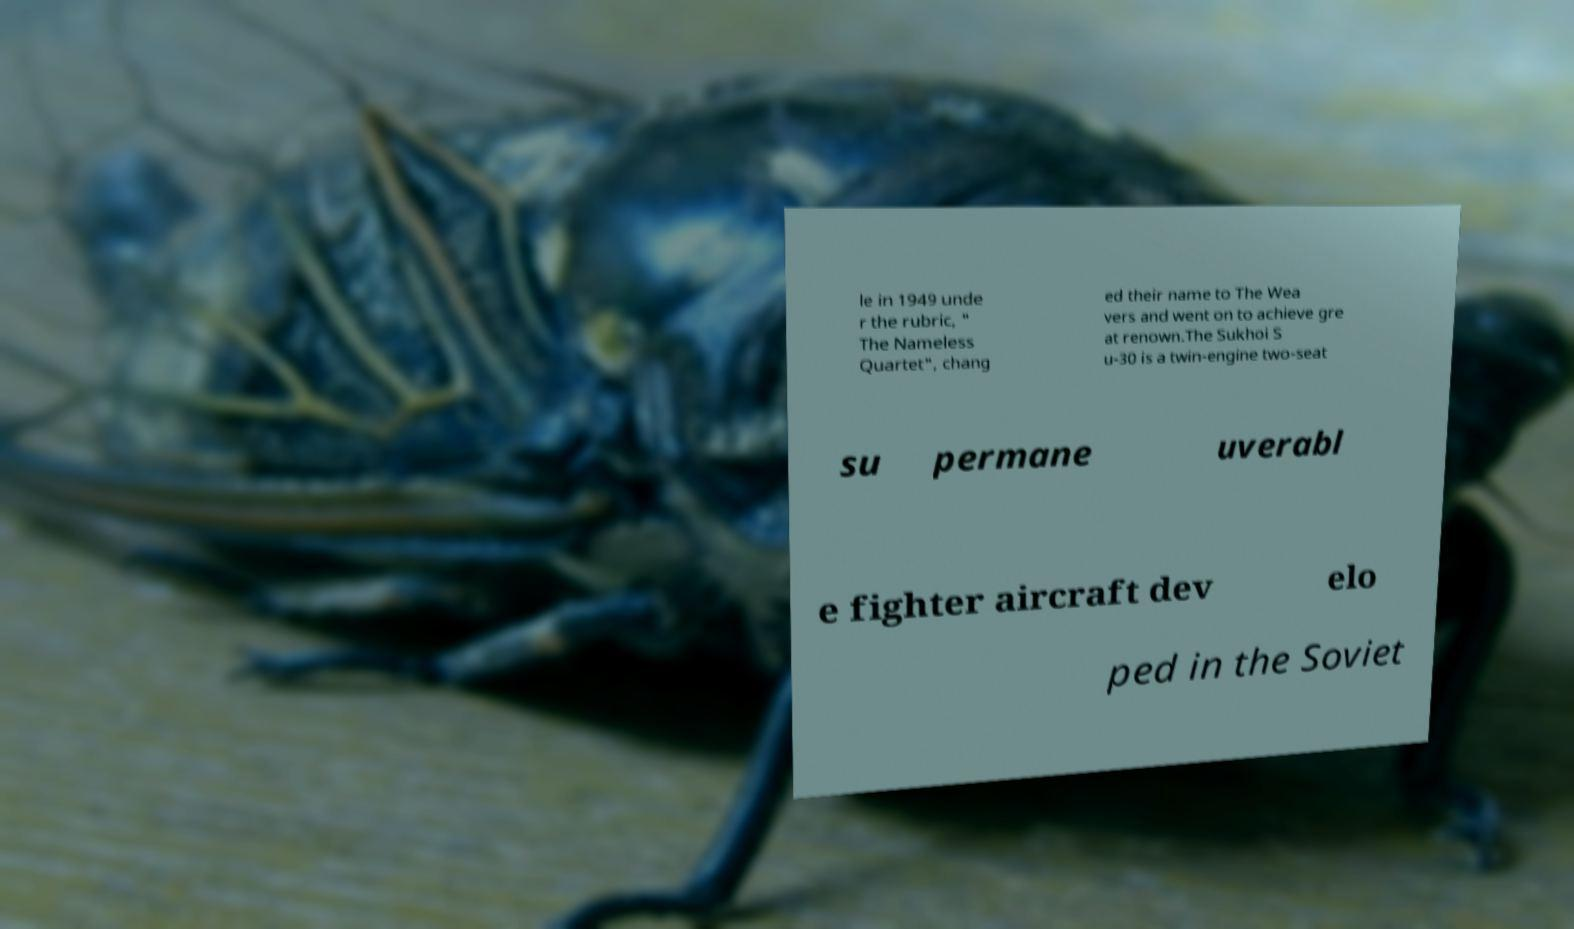I need the written content from this picture converted into text. Can you do that? le in 1949 unde r the rubric, " The Nameless Quartet", chang ed their name to The Wea vers and went on to achieve gre at renown.The Sukhoi S u-30 is a twin-engine two-seat su permane uverabl e fighter aircraft dev elo ped in the Soviet 